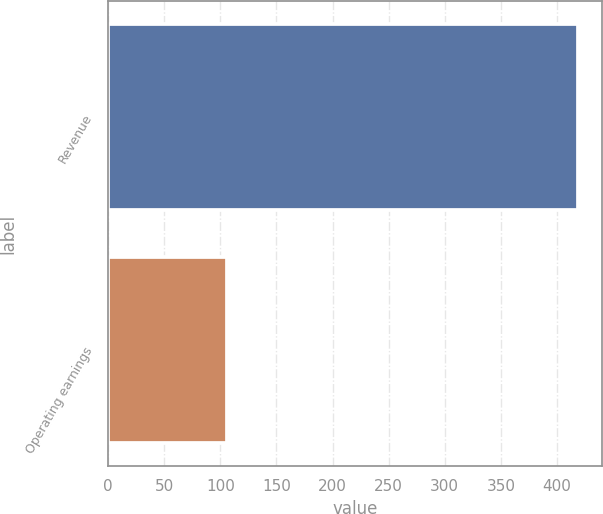Convert chart to OTSL. <chart><loc_0><loc_0><loc_500><loc_500><bar_chart><fcel>Revenue<fcel>Operating earnings<nl><fcel>419<fcel>106<nl></chart> 